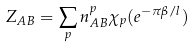<formula> <loc_0><loc_0><loc_500><loc_500>Z _ { A B } = \sum _ { p } n ^ { p } _ { A B } \chi _ { p } ( e ^ { - \pi \beta / l } )</formula> 